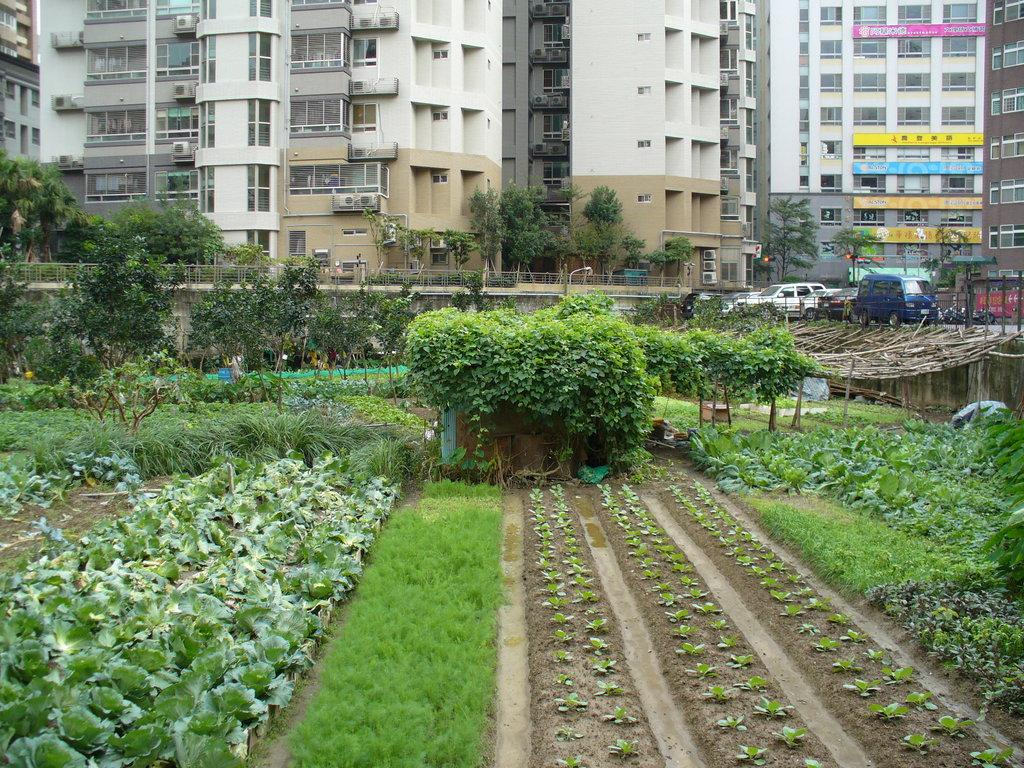What type of structures can be seen in the image? There are buildings in the image. What appliances are present on the buildings? Air conditioners are present in the image. What is the main feature of the landscape in the image? There is a road in the image. What type of barrier is visible in the image? An iron grill is visible in the image. What are the vehicles on the road in the image? Motor vehicles are on the road in the image. What type of vegetation can be seen in the image? Trees, plants, shrubs, bushes, grass, and creepers are present in the image. What historical event is being commemorated by the kitty in the image? There is no kitty present in the image, and therefore no historical event can be associated with it. What type of dish is the cook preparing in the image? There is no cook or dish preparation present in the image. 